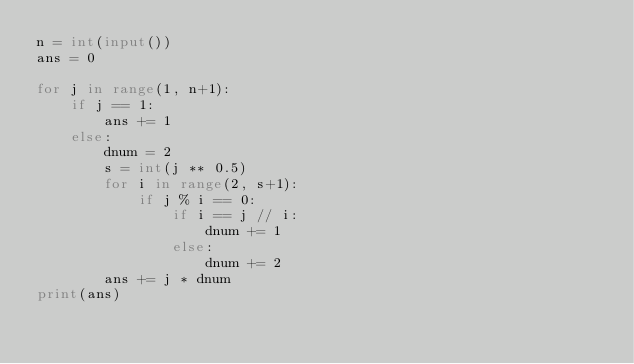Convert code to text. <code><loc_0><loc_0><loc_500><loc_500><_Python_>n = int(input())
ans = 0

for j in range(1, n+1):
    if j == 1:
        ans += 1
    else:
        dnum = 2
        s = int(j ** 0.5)
        for i in range(2, s+1):
            if j % i == 0:
                if i == j // i:
                    dnum += 1
                else:
                    dnum += 2
        ans += j * dnum
print(ans)</code> 